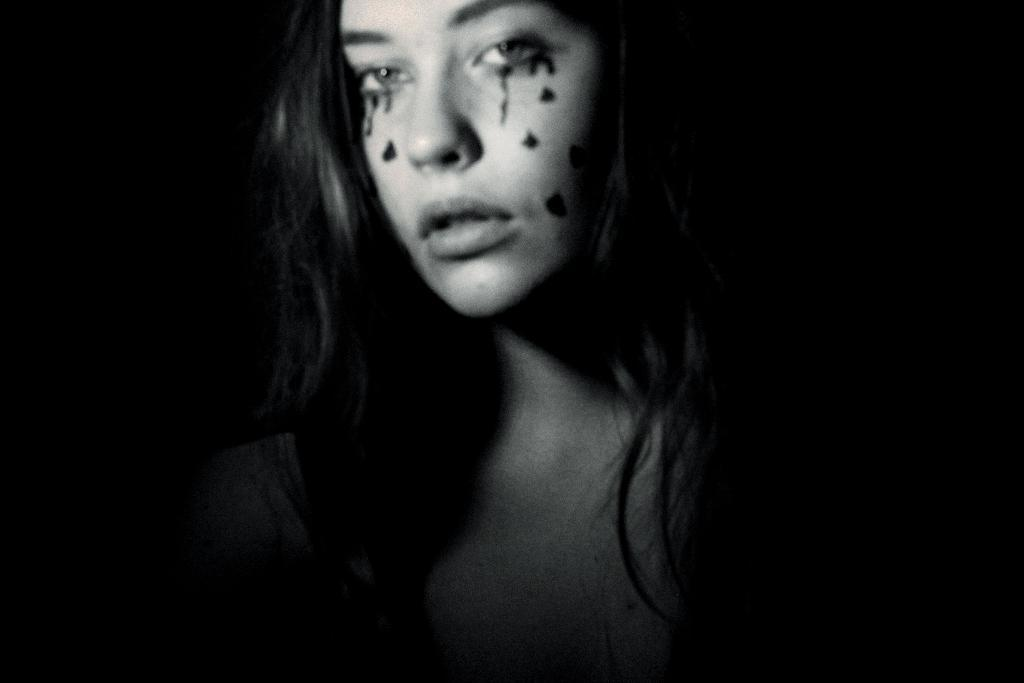What is the color scheme of the image? The image is black and white. Can you describe the main subject in the image? There is a girl in the image. What type of slave is depicted in the image? There is no slave present in the image; it features a girl. What color is the cream used in the image? There is no cream present in the image. 